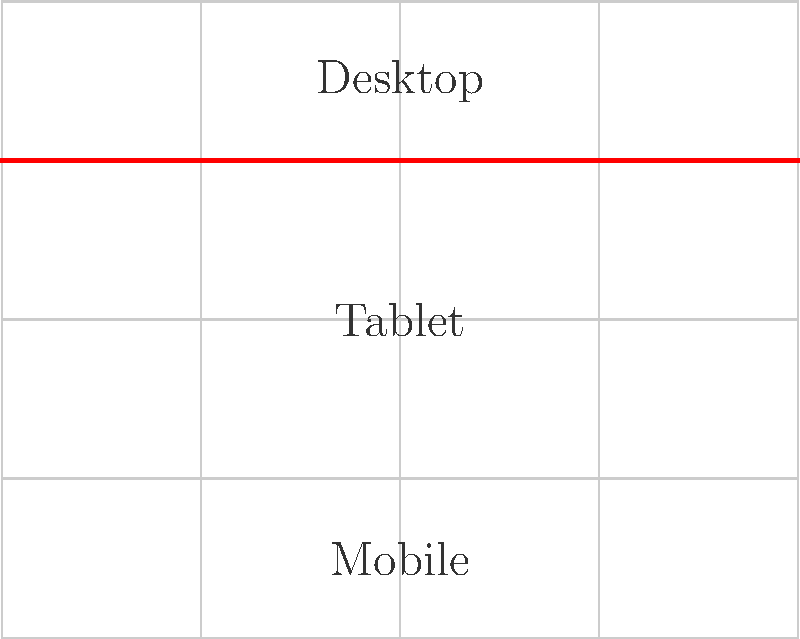Given the responsive grid layout shown above, which CSS property would you use to define the breakpoints for different screen sizes, and how would you implement the breakpoints at 768px and 480px? To create a responsive grid layout with breakpoints, follow these steps:

1. Use CSS Grid for the layout:
   - Define a container with `display: grid;`
   - Set up columns using `grid-template-columns`

2. Implement breakpoints using media queries:
   - Media queries allow you to apply different styles based on screen width
   - Use `@media` rule to define breakpoints

3. For the 768px breakpoint (Tablet):
   ```css
   @media (max-width: 768px) {
     .container {
       grid-template-columns: repeat(2, 1fr);
     }
   }
   ```

4. For the 480px breakpoint (Mobile):
   ```css
   @media (max-width: 480px) {
     .container {
       grid-template-columns: 1fr;
     }
   }
   ```

5. The `max-width` in media queries defines the breakpoint
   - Styles inside each media query apply when screen width is below the specified value

6. Use `grid-template-columns` to adjust the number of columns at each breakpoint
   - Desktop (default): 3 or 4 columns
   - Tablet: 2 columns
   - Mobile: 1 column

The key property for implementing breakpoints is `@media` with `max-width`.
Answer: @media with max-width 